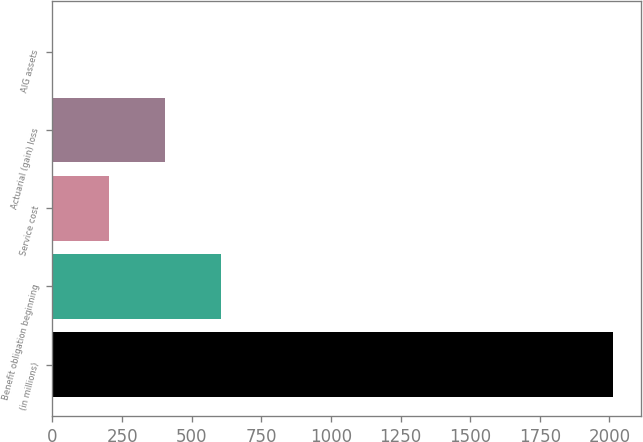Convert chart. <chart><loc_0><loc_0><loc_500><loc_500><bar_chart><fcel>(in millions)<fcel>Benefit obligation beginning<fcel>Service cost<fcel>Actuarial (gain) loss<fcel>AIG assets<nl><fcel>2014<fcel>604.9<fcel>202.3<fcel>403.6<fcel>1<nl></chart> 